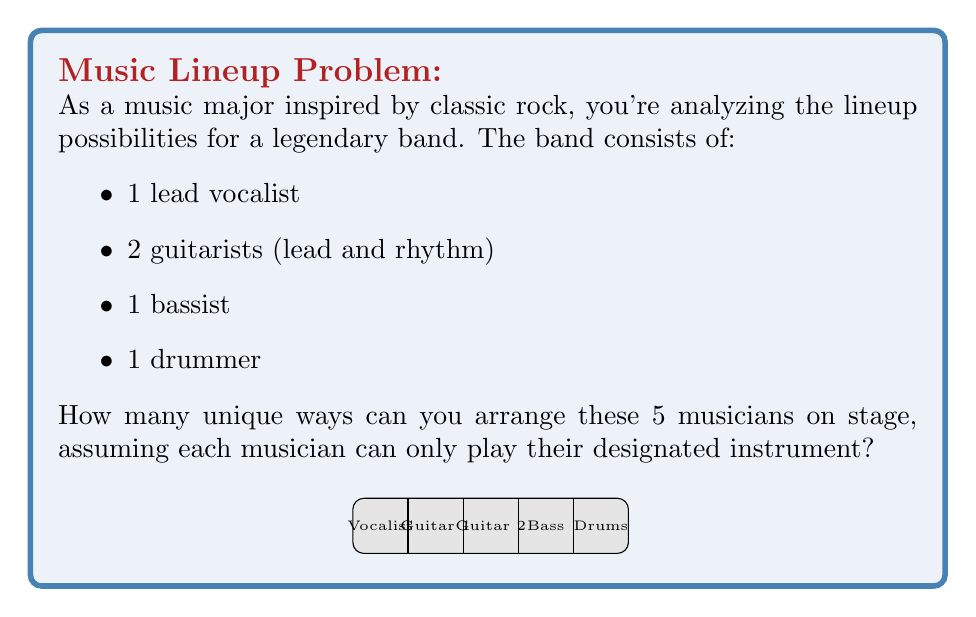Help me with this question. Let's approach this step-by-step using permutation principles:

1) First, we need to recognize that this is a permutation problem. We're arranging all 5 musicians, and the order matters (their position on stage).

2) In a standard permutation of 5 distinct objects, we would have 5! (5 factorial) arrangements. However, we need to account for the fact that the two guitarists are interchangeable in their roles.

3) The formula for permutations with repeated elements is:

   $$\frac{n!}{n_1! \cdot n_2! \cdot ... \cdot n_k!}$$

   Where $n$ is the total number of elements, and $n_1, n_2, ..., n_k$ are the numbers of each repeated element.

4) In our case:
   $n = 5$ (total musicians)
   $n_1 = 2$ (two guitarists)
   
   All other musicians are unique, so they don't affect the denominator.

5) Plugging into our formula:

   $$\frac{5!}{2!} = \frac{5 \cdot 4 \cdot 3 \cdot 2 \cdot 1}{2 \cdot 1} = \frac{120}{2} = 60$$

Therefore, there are 60 unique ways to arrange the band members on stage.
Answer: 60 unique arrangements 